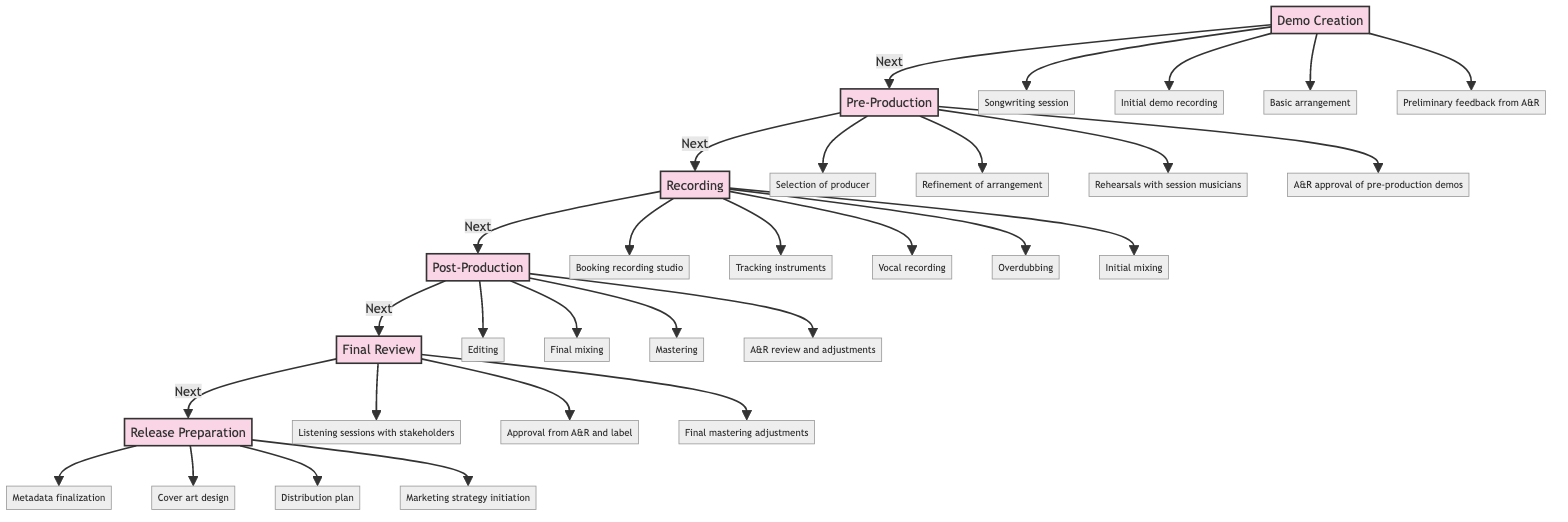What is the first stage of the timeline? The diagram shows "Demo Creation" as the starting point of the timeline, which is labeled at the top as the first stage.
Answer: Demo Creation How many activities are listed under "Recording"? The "Recording" stage includes five distinct activities as indicated in the diagram: Booking recording studio, Tracking instruments, Vocal recording, Overdubbing, and Initial mixing.
Answer: 5 Which stage follows "Post-Production"? The diagram clearly indicates that "Final Review" is the stage that comes directly after "Post-Production" in the flow of the timeline.
Answer: Final Review What type of feedback is mentioned in "Demo Creation"? The "Demo Creation" stage includes "Preliminary feedback from A&R" as a key activity, indicating it's the type of feedback specific to this stage.
Answer: Preliminary feedback In which stage do you select a producer? The selection of a producer occurs in the "Pre-Production" stage as described in the flowchart.
Answer: Pre-Production How many stages are there in total? By analyzing the diagram, there are six stages outlined, from "Demo Creation" to "Release Preparation."
Answer: 6 What is the last activity before the release of the music? The diagram shows that "Marketing strategy initiation" is the last activity listed under the "Release Preparation" stage, which comes right before the music is released.
Answer: Marketing strategy initiation What activity follows "Final mixing"? The diagram indicates that "Mastering" follows the "Final mixing" activity in the "Post-Production" stage, as the order of activities is directly shown.
Answer: Mastering What stage requires A&R approval for the pre-production demos? The stage "Pre-Production" contains an activity that states "A&R approval of pre-production demos," indicating that this is where the approval is required.
Answer: Pre-Production 